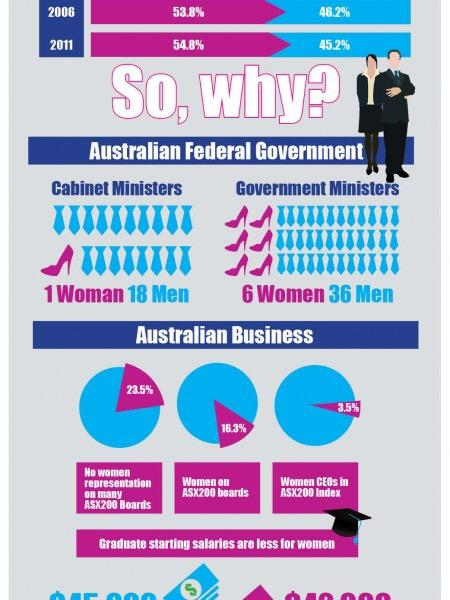List a handful of essential elements in this visual. The gender of Cabinet Ministers that least dominates in the Australian Federal Government is female. The gender of CEOs that most dominate in the Australian business industry is male. In the Australian Federal Government, female Government Ministers are the least dominant gender. In Australia, female CEOs are underrepresented compared to male CEOs in the business world. The majority of government ministers in the Australian Federal Government are male. 